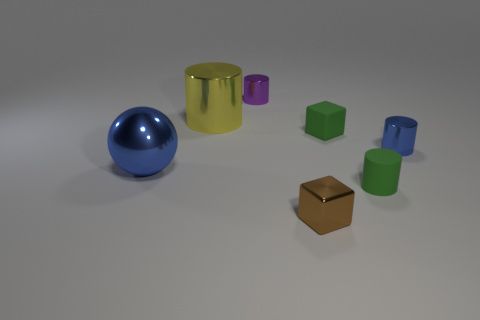What kind of environment do these objects seem to be in, and what does that tell us about their context or usage? The objects appear to be staged in a nondescript environment, possibly within a studio setting designed for display or photography purposes. This minimalist background hints that the objects could be utilized for educational demonstrations, visual presentations, or artistic compositions, rather than being situated within a natural or domestically functional setting. 